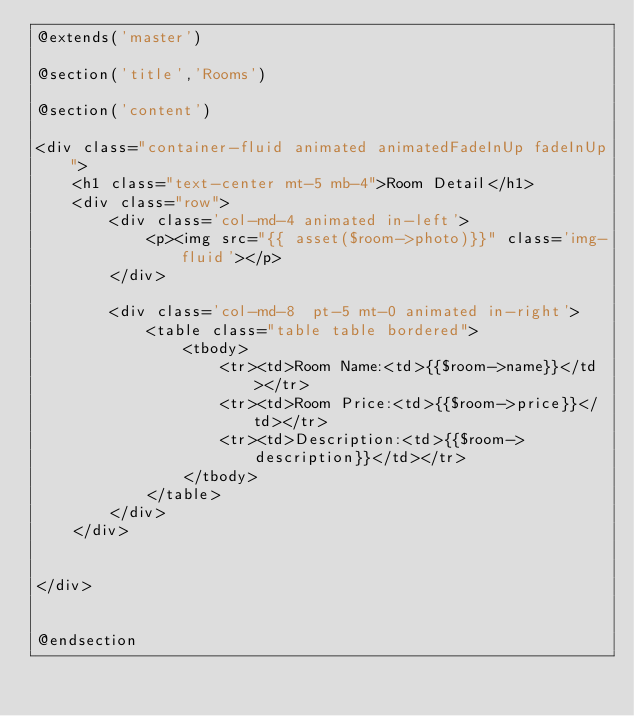Convert code to text. <code><loc_0><loc_0><loc_500><loc_500><_PHP_>@extends('master')

@section('title','Rooms')

@section('content')

<div class="container-fluid animated animatedFadeInUp fadeInUp">
	<h1 class="text-center mt-5 mb-4">Room Detail</h1>
	<div class="row">
		<div class='col-md-4 animated in-left'>
			<p><img src="{{ asset($room->photo)}}" class='img-fluid'></p>
		</div>

		<div class='col-md-8  pt-5 mt-0 animated in-right'>
			<table class="table table bordered">
				<tbody>
					<tr><td>Room Name:<td>{{$room->name}}</td></tr>
					<tr><td>Room Price:<td>{{$room->price}}</td></tr>
					<tr><td>Description:<td>{{$room->description}}</td></tr>
				</tbody>
			</table>
		</div>
	</div>


</div>
	  

@endsection</code> 